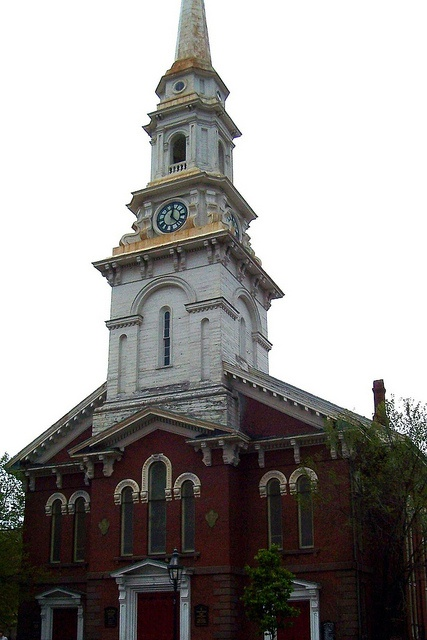Describe the objects in this image and their specific colors. I can see clock in white, black, gray, blue, and darkgray tones and clock in white, gray, and black tones in this image. 